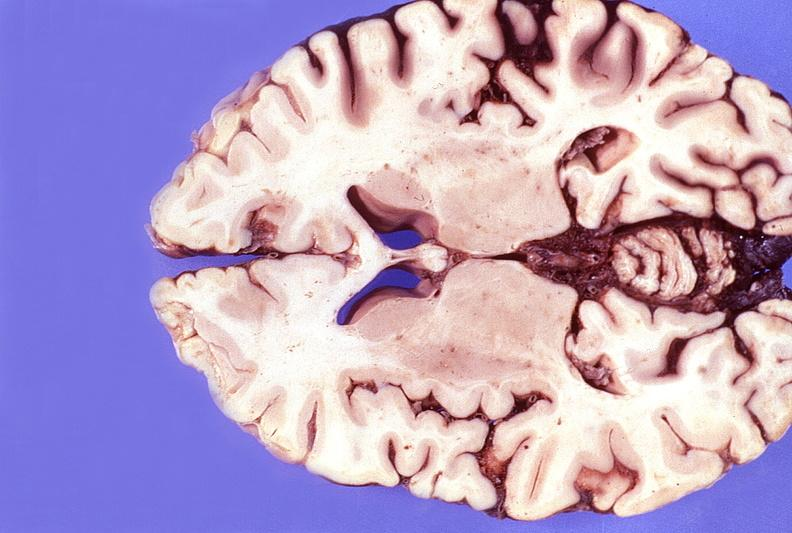does chromophobe adenoma show normal brain?
Answer the question using a single word or phrase. No 